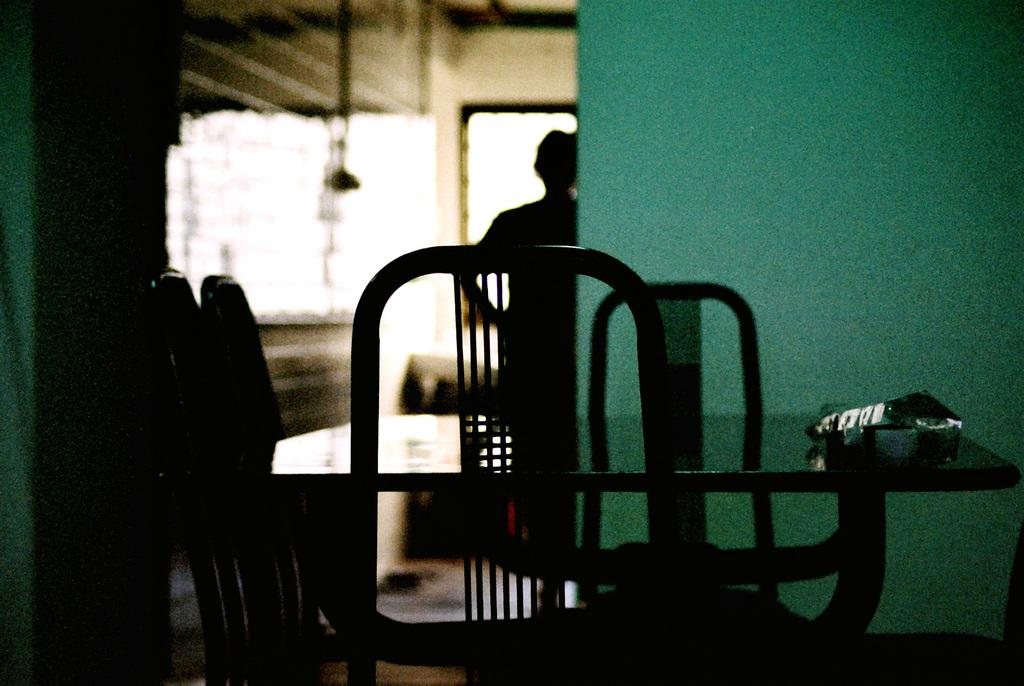What objects are in the foreground of the image? There is a group of chairs and a table in the foreground of the image. Can you describe the person in the background of the image? There is a person in the background of the image, but no specific details about the person are provided. What is visible in the background of the image? There is a window in the background of the image. What type of attraction is the person in the image visiting? There is no indication in the image that the person is visiting an attraction, so it cannot be determined from the picture. 